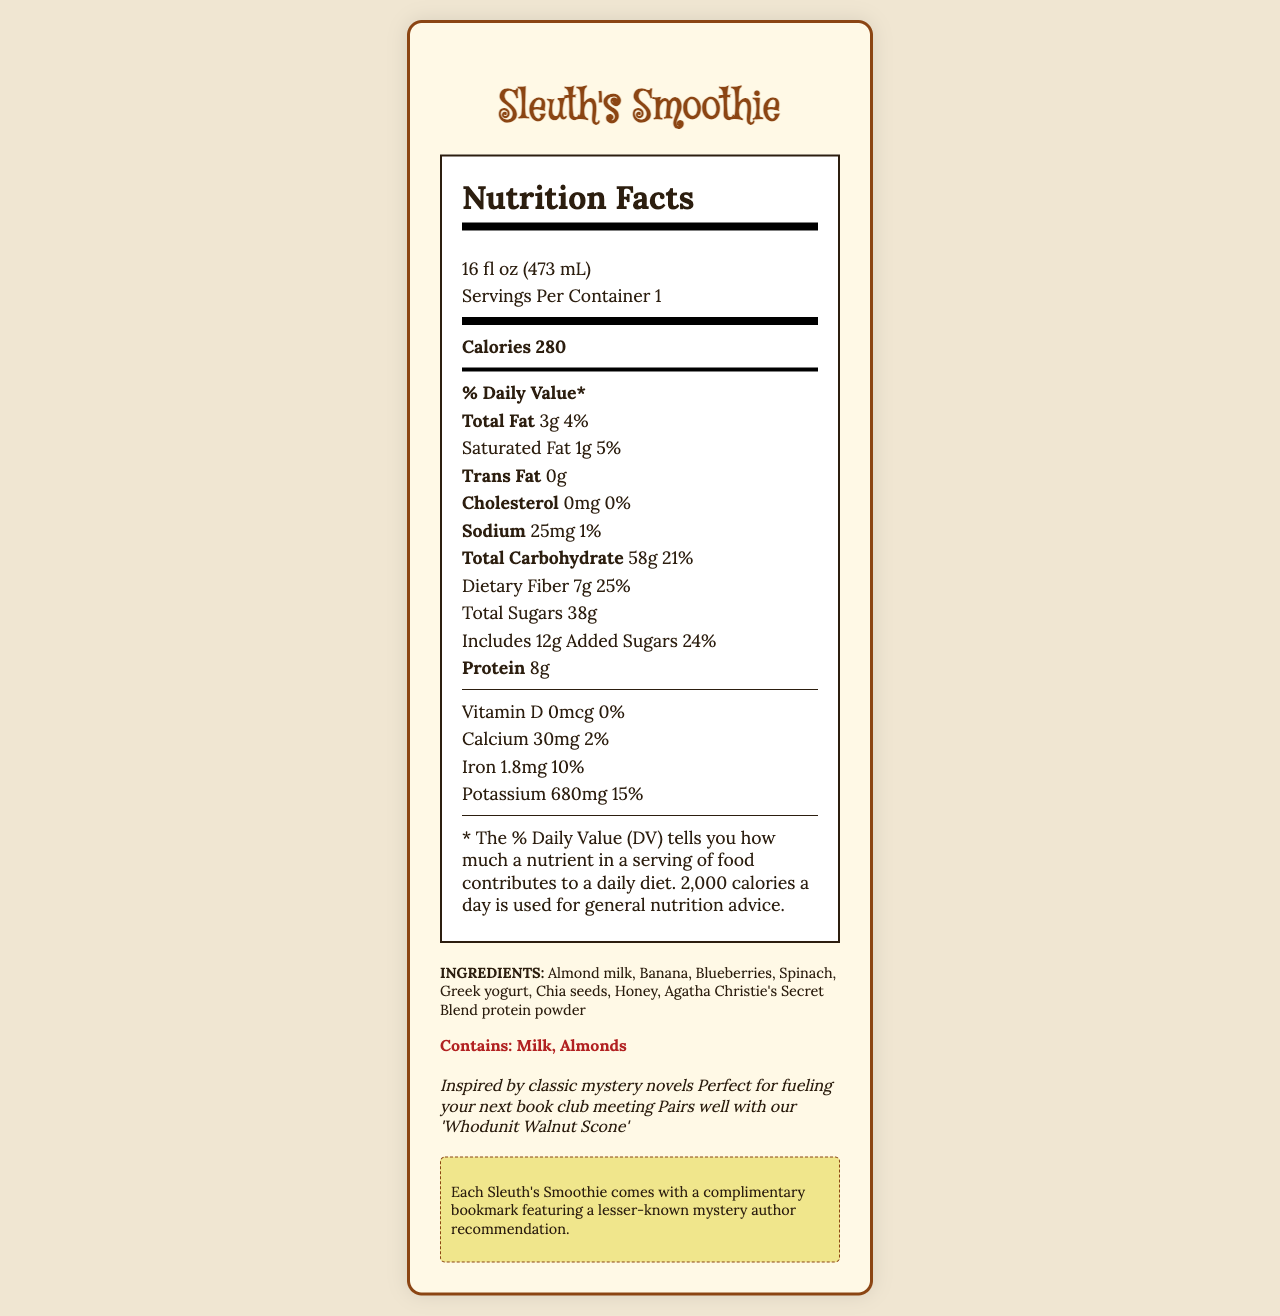What is the serving size of the Sleuth's Smoothie? The serving size is stated in the first part of the document under the nutrition facts header.
Answer: 16 fl oz (473 mL) How many calories are in one serving of Sleuth's Smoothie? The document lists the calorie content as 280 under the nutrition facts section.
Answer: 280 What is the % Daily Value of dietary fiber in one serving? The % Daily Value of dietary fiber is explicitly stated as 25% within the nutrition facts section.
Answer: 25% How much protein does the Sleuth's Smoothie contain per serving? The protein content is given as 8g in the nutrition facts section.
Answer: 8g Is there any trans fat in the Sleuth's Smoothie? The document lists the trans fat content as 0g.
Answer: No Which ingredients in the Sleuth’s Smoothie contain nuts? A. Greek yogurt B. Chia seeds C. Almond milk D. Blueberries The document specifies that the allergens include milk and almonds.
Answer: C. Almond milk How many grams of added sugars does the Sleuth’s Smoothie include? The document states that the smoothie contains 12g of added sugars.
Answer: 12g What is the % Daily Value for calcium in one serving? The % Daily Value for calcium is mentioned as 2% in the nutrition facts section.
Answer: 2% Does the Sleuth's Smoothie contain any cholesterol? The nutrition facts section lists the cholesterol amount as 0mg with a % Daily Value of 0%.
Answer: No Which vitamin is not present in the Sleuth's Smoothie? A. Vitamin D B. Vitamin C C. Vitamin B12 The document mentions that the amount of Vitamin D is 0mcg with a % Daily Value of 0%.
Answer: A. Vitamin D Is the Sleuth's Smoothie suitable for someone with a milk allergy? The document lists "Contains: Milk, Almonds" under the allergens section.
Answer: No What is the main idea of the Sleuth's Smoothie Nutrition Facts document? The document includes the product name, serving size, nutritional values including calories, total fat, cholesterol, sodium, carbohydrates, dietary information, proteins, vitamins, and minerals, along with an ingredients list, allergens, additional anecdotes, and a bookstore café note.
Answer: The document provides detailed nutritional information, ingredients list, allergens, and additional notes for the Sleuth's Smoothie available at a neighborhood bookstore café. What is the total sugar content in the Sleuth's Smoothie? The document lists the total sugars as 38g under the nutrition facts section.
Answer: 38g What specific note is provided by the bookstore café regarding the Sleuth's Smoothie? This information is available under the bookstore café note section at the end of the document.
Answer: Each Sleuth's Smoothie comes with a complimentary bookmark featuring a lesser-known mystery author recommendation. What brand of protein powder is used in the Sleuth's Smoothie? This ingredient is mentioned in the ingredients list in the document.
Answer: Agatha Christie's Secret Blend protein powder Can I determine if the smoothie is vegan from the information provided? The document mentions milk and honey as ingredients, but does not provide complete details on whether other ingredients or the protein powder contain any animal products.
Answer: Not enough information 